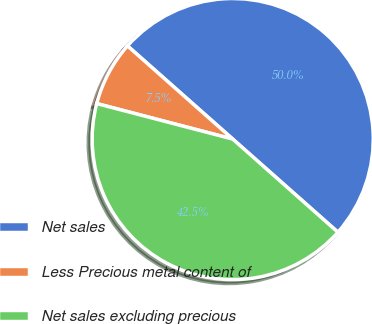Convert chart to OTSL. <chart><loc_0><loc_0><loc_500><loc_500><pie_chart><fcel>Net sales<fcel>Less Precious metal content of<fcel>Net sales excluding precious<nl><fcel>50.0%<fcel>7.47%<fcel>42.53%<nl></chart> 